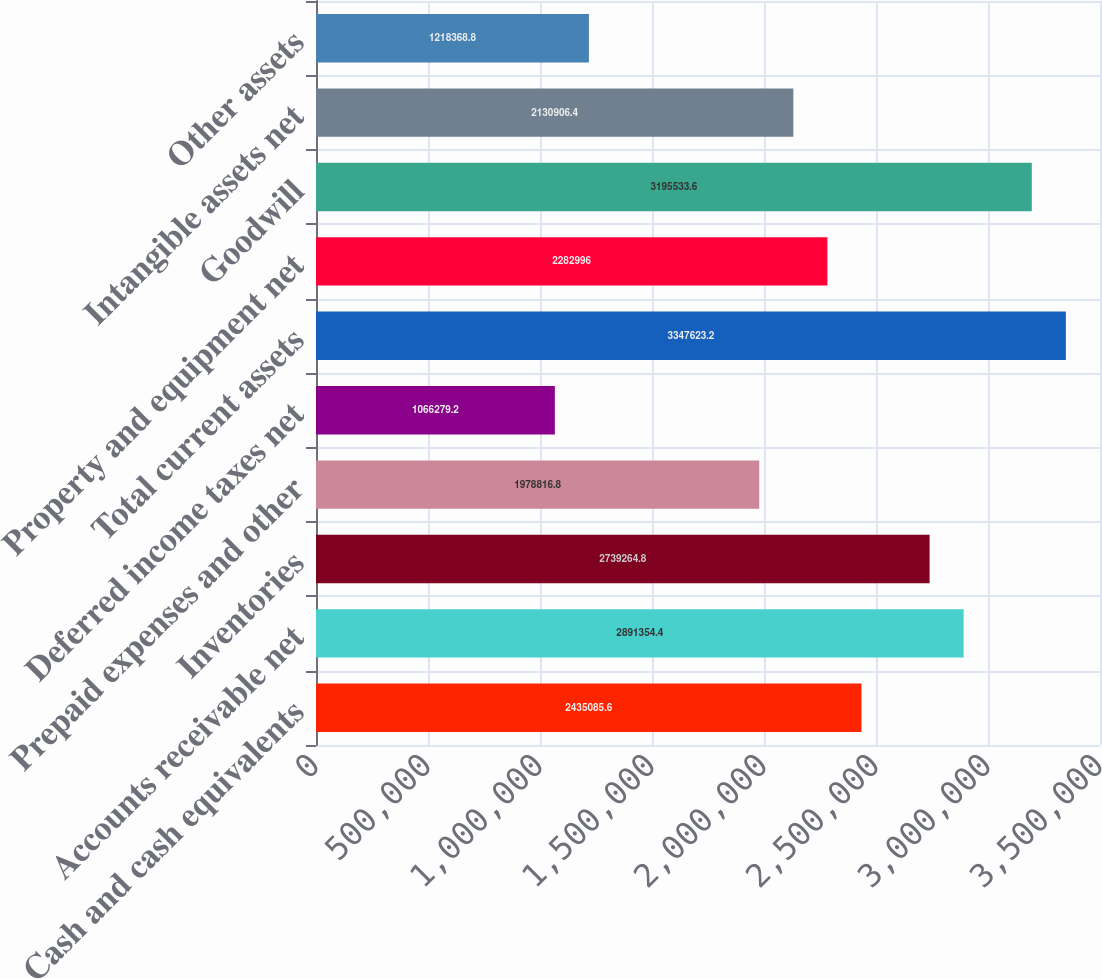Convert chart to OTSL. <chart><loc_0><loc_0><loc_500><loc_500><bar_chart><fcel>Cash and cash equivalents<fcel>Accounts receivable net<fcel>Inventories<fcel>Prepaid expenses and other<fcel>Deferred income taxes net<fcel>Total current assets<fcel>Property and equipment net<fcel>Goodwill<fcel>Intangible assets net<fcel>Other assets<nl><fcel>2.43509e+06<fcel>2.89135e+06<fcel>2.73926e+06<fcel>1.97882e+06<fcel>1.06628e+06<fcel>3.34762e+06<fcel>2.283e+06<fcel>3.19553e+06<fcel>2.13091e+06<fcel>1.21837e+06<nl></chart> 